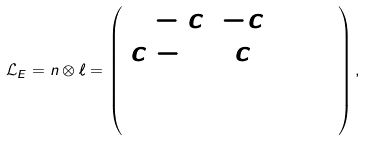Convert formula to latex. <formula><loc_0><loc_0><loc_500><loc_500>\mathcal { L } _ { E } = n \otimes \ell = \left ( \begin{array} { c c c c } 1 - c & - c & 0 & 0 \\ c - 1 & c & 0 & 0 \\ 0 & 0 & 0 & 0 \\ 0 & 0 & 0 & 0 \end{array} \right ) ,</formula> 